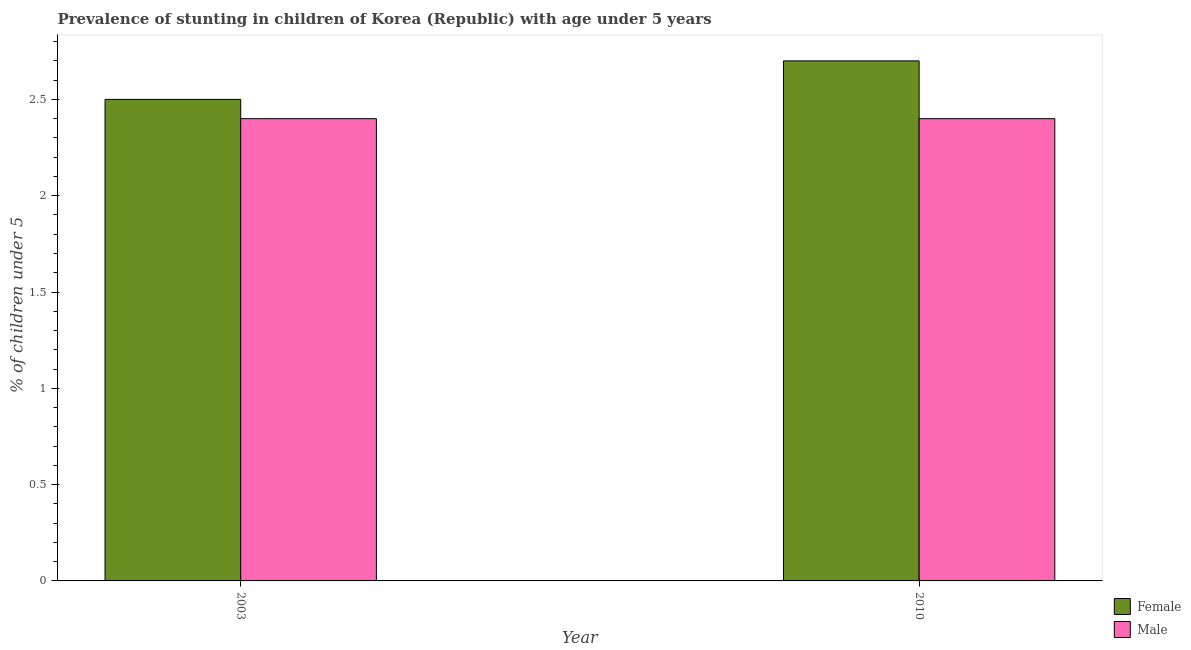How many bars are there on the 1st tick from the right?
Offer a terse response. 2. What is the label of the 2nd group of bars from the left?
Your answer should be very brief. 2010. In how many cases, is the number of bars for a given year not equal to the number of legend labels?
Offer a terse response. 0. What is the percentage of stunted female children in 2003?
Provide a succinct answer. 2.5. Across all years, what is the maximum percentage of stunted female children?
Provide a short and direct response. 2.7. Across all years, what is the minimum percentage of stunted male children?
Your answer should be compact. 2.4. What is the total percentage of stunted male children in the graph?
Make the answer very short. 4.8. What is the average percentage of stunted female children per year?
Provide a succinct answer. 2.6. In the year 2010, what is the difference between the percentage of stunted male children and percentage of stunted female children?
Offer a very short reply. 0. What is the ratio of the percentage of stunted male children in 2003 to that in 2010?
Keep it short and to the point. 1. Is the percentage of stunted female children in 2003 less than that in 2010?
Offer a terse response. Yes. In how many years, is the percentage of stunted female children greater than the average percentage of stunted female children taken over all years?
Give a very brief answer. 1. What does the 2nd bar from the left in 2003 represents?
Make the answer very short. Male. Are all the bars in the graph horizontal?
Offer a terse response. No. What is the difference between two consecutive major ticks on the Y-axis?
Your answer should be very brief. 0.5. Does the graph contain grids?
Make the answer very short. No. Where does the legend appear in the graph?
Keep it short and to the point. Bottom right. How are the legend labels stacked?
Provide a succinct answer. Vertical. What is the title of the graph?
Give a very brief answer. Prevalence of stunting in children of Korea (Republic) with age under 5 years. Does "Highest 10% of population" appear as one of the legend labels in the graph?
Offer a terse response. No. What is the label or title of the X-axis?
Provide a succinct answer. Year. What is the label or title of the Y-axis?
Your answer should be very brief.  % of children under 5. What is the  % of children under 5 in Male in 2003?
Ensure brevity in your answer.  2.4. What is the  % of children under 5 in Female in 2010?
Offer a terse response. 2.7. What is the  % of children under 5 in Male in 2010?
Make the answer very short. 2.4. Across all years, what is the maximum  % of children under 5 of Female?
Ensure brevity in your answer.  2.7. Across all years, what is the maximum  % of children under 5 in Male?
Provide a short and direct response. 2.4. Across all years, what is the minimum  % of children under 5 in Male?
Provide a succinct answer. 2.4. What is the total  % of children under 5 in Female in the graph?
Ensure brevity in your answer.  5.2. What is the total  % of children under 5 in Male in the graph?
Your answer should be compact. 4.8. What is the difference between the  % of children under 5 in Female in 2003 and that in 2010?
Your answer should be very brief. -0.2. What is the difference between the  % of children under 5 of Female in 2003 and the  % of children under 5 of Male in 2010?
Your answer should be very brief. 0.1. What is the average  % of children under 5 of Female per year?
Provide a short and direct response. 2.6. What is the average  % of children under 5 of Male per year?
Offer a terse response. 2.4. What is the ratio of the  % of children under 5 in Female in 2003 to that in 2010?
Give a very brief answer. 0.93. What is the difference between the highest and the second highest  % of children under 5 of Female?
Offer a very short reply. 0.2. What is the difference between the highest and the lowest  % of children under 5 of Male?
Your response must be concise. 0. 